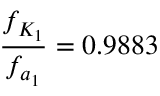Convert formula to latex. <formula><loc_0><loc_0><loc_500><loc_500>\frac { f _ { K _ { 1 } } } { f _ { a _ { 1 } } } = 0 . 9 8 8 3</formula> 